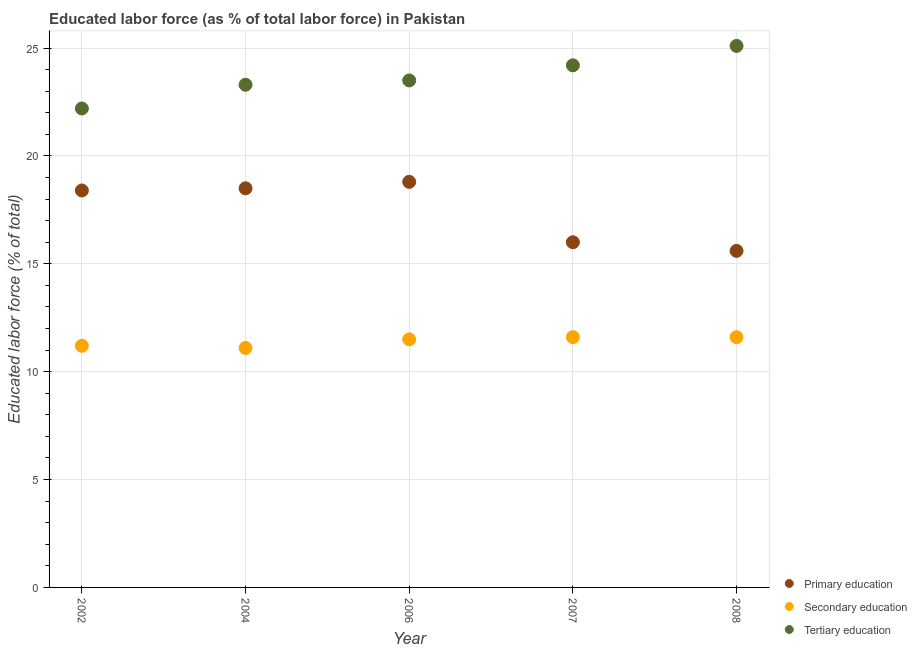How many different coloured dotlines are there?
Ensure brevity in your answer.  3. What is the percentage of labor force who received secondary education in 2002?
Make the answer very short. 11.2. Across all years, what is the maximum percentage of labor force who received secondary education?
Offer a very short reply. 11.6. Across all years, what is the minimum percentage of labor force who received tertiary education?
Your answer should be very brief. 22.2. In which year was the percentage of labor force who received tertiary education minimum?
Offer a terse response. 2002. What is the total percentage of labor force who received tertiary education in the graph?
Your response must be concise. 118.3. What is the difference between the percentage of labor force who received secondary education in 2006 and that in 2008?
Keep it short and to the point. -0.1. What is the difference between the percentage of labor force who received primary education in 2004 and the percentage of labor force who received tertiary education in 2008?
Your response must be concise. -6.6. What is the average percentage of labor force who received primary education per year?
Keep it short and to the point. 17.46. In the year 2004, what is the difference between the percentage of labor force who received primary education and percentage of labor force who received tertiary education?
Provide a short and direct response. -4.8. What is the ratio of the percentage of labor force who received primary education in 2002 to that in 2006?
Give a very brief answer. 0.98. What is the difference between the highest and the second highest percentage of labor force who received primary education?
Provide a succinct answer. 0.3. What is the difference between the highest and the lowest percentage of labor force who received primary education?
Provide a short and direct response. 3.2. Is it the case that in every year, the sum of the percentage of labor force who received primary education and percentage of labor force who received secondary education is greater than the percentage of labor force who received tertiary education?
Keep it short and to the point. Yes. Is the percentage of labor force who received primary education strictly greater than the percentage of labor force who received tertiary education over the years?
Make the answer very short. No. How many years are there in the graph?
Offer a very short reply. 5. What is the difference between two consecutive major ticks on the Y-axis?
Keep it short and to the point. 5. Are the values on the major ticks of Y-axis written in scientific E-notation?
Your response must be concise. No. Where does the legend appear in the graph?
Offer a very short reply. Bottom right. How many legend labels are there?
Provide a succinct answer. 3. What is the title of the graph?
Ensure brevity in your answer.  Educated labor force (as % of total labor force) in Pakistan. Does "Industrial Nitrous Oxide" appear as one of the legend labels in the graph?
Your answer should be compact. No. What is the label or title of the Y-axis?
Give a very brief answer. Educated labor force (% of total). What is the Educated labor force (% of total) of Primary education in 2002?
Keep it short and to the point. 18.4. What is the Educated labor force (% of total) of Secondary education in 2002?
Your response must be concise. 11.2. What is the Educated labor force (% of total) in Tertiary education in 2002?
Provide a succinct answer. 22.2. What is the Educated labor force (% of total) in Primary education in 2004?
Offer a very short reply. 18.5. What is the Educated labor force (% of total) in Secondary education in 2004?
Offer a terse response. 11.1. What is the Educated labor force (% of total) of Tertiary education in 2004?
Provide a succinct answer. 23.3. What is the Educated labor force (% of total) in Primary education in 2006?
Offer a very short reply. 18.8. What is the Educated labor force (% of total) in Tertiary education in 2006?
Your answer should be very brief. 23.5. What is the Educated labor force (% of total) in Primary education in 2007?
Your answer should be very brief. 16. What is the Educated labor force (% of total) of Secondary education in 2007?
Offer a terse response. 11.6. What is the Educated labor force (% of total) of Tertiary education in 2007?
Ensure brevity in your answer.  24.2. What is the Educated labor force (% of total) in Primary education in 2008?
Offer a terse response. 15.6. What is the Educated labor force (% of total) in Secondary education in 2008?
Keep it short and to the point. 11.6. What is the Educated labor force (% of total) in Tertiary education in 2008?
Your answer should be compact. 25.1. Across all years, what is the maximum Educated labor force (% of total) of Primary education?
Make the answer very short. 18.8. Across all years, what is the maximum Educated labor force (% of total) in Secondary education?
Keep it short and to the point. 11.6. Across all years, what is the maximum Educated labor force (% of total) of Tertiary education?
Offer a very short reply. 25.1. Across all years, what is the minimum Educated labor force (% of total) in Primary education?
Provide a short and direct response. 15.6. Across all years, what is the minimum Educated labor force (% of total) of Secondary education?
Offer a very short reply. 11.1. Across all years, what is the minimum Educated labor force (% of total) of Tertiary education?
Ensure brevity in your answer.  22.2. What is the total Educated labor force (% of total) in Primary education in the graph?
Keep it short and to the point. 87.3. What is the total Educated labor force (% of total) in Secondary education in the graph?
Offer a terse response. 57. What is the total Educated labor force (% of total) of Tertiary education in the graph?
Provide a succinct answer. 118.3. What is the difference between the Educated labor force (% of total) in Primary education in 2002 and that in 2004?
Your answer should be compact. -0.1. What is the difference between the Educated labor force (% of total) of Tertiary education in 2002 and that in 2004?
Offer a very short reply. -1.1. What is the difference between the Educated labor force (% of total) in Primary education in 2002 and that in 2006?
Your response must be concise. -0.4. What is the difference between the Educated labor force (% of total) in Primary education in 2002 and that in 2007?
Your answer should be very brief. 2.4. What is the difference between the Educated labor force (% of total) in Secondary education in 2002 and that in 2008?
Your answer should be very brief. -0.4. What is the difference between the Educated labor force (% of total) of Tertiary education in 2004 and that in 2007?
Provide a succinct answer. -0.9. What is the difference between the Educated labor force (% of total) in Primary education in 2004 and that in 2008?
Provide a short and direct response. 2.9. What is the difference between the Educated labor force (% of total) of Primary education in 2006 and that in 2007?
Provide a short and direct response. 2.8. What is the difference between the Educated labor force (% of total) in Primary education in 2006 and that in 2008?
Your answer should be compact. 3.2. What is the difference between the Educated labor force (% of total) of Secondary education in 2007 and that in 2008?
Make the answer very short. 0. What is the difference between the Educated labor force (% of total) in Primary education in 2002 and the Educated labor force (% of total) in Tertiary education in 2004?
Your answer should be very brief. -4.9. What is the difference between the Educated labor force (% of total) of Secondary education in 2002 and the Educated labor force (% of total) of Tertiary education in 2004?
Make the answer very short. -12.1. What is the difference between the Educated labor force (% of total) of Primary education in 2002 and the Educated labor force (% of total) of Secondary education in 2006?
Ensure brevity in your answer.  6.9. What is the difference between the Educated labor force (% of total) of Primary education in 2002 and the Educated labor force (% of total) of Secondary education in 2007?
Provide a short and direct response. 6.8. What is the difference between the Educated labor force (% of total) of Primary education in 2002 and the Educated labor force (% of total) of Tertiary education in 2007?
Offer a terse response. -5.8. What is the difference between the Educated labor force (% of total) in Primary education in 2002 and the Educated labor force (% of total) in Secondary education in 2008?
Provide a short and direct response. 6.8. What is the difference between the Educated labor force (% of total) in Primary education in 2002 and the Educated labor force (% of total) in Tertiary education in 2008?
Ensure brevity in your answer.  -6.7. What is the difference between the Educated labor force (% of total) of Primary education in 2004 and the Educated labor force (% of total) of Tertiary education in 2006?
Offer a terse response. -5. What is the difference between the Educated labor force (% of total) of Primary education in 2004 and the Educated labor force (% of total) of Secondary education in 2007?
Your answer should be compact. 6.9. What is the difference between the Educated labor force (% of total) of Primary education in 2004 and the Educated labor force (% of total) of Tertiary education in 2007?
Your response must be concise. -5.7. What is the difference between the Educated labor force (% of total) of Primary education in 2004 and the Educated labor force (% of total) of Secondary education in 2008?
Offer a terse response. 6.9. What is the difference between the Educated labor force (% of total) of Primary education in 2004 and the Educated labor force (% of total) of Tertiary education in 2008?
Provide a succinct answer. -6.6. What is the difference between the Educated labor force (% of total) in Primary education in 2006 and the Educated labor force (% of total) in Secondary education in 2007?
Your answer should be very brief. 7.2. What is the difference between the Educated labor force (% of total) in Primary education in 2006 and the Educated labor force (% of total) in Tertiary education in 2008?
Keep it short and to the point. -6.3. What is the difference between the Educated labor force (% of total) in Secondary education in 2006 and the Educated labor force (% of total) in Tertiary education in 2008?
Give a very brief answer. -13.6. What is the difference between the Educated labor force (% of total) of Primary education in 2007 and the Educated labor force (% of total) of Secondary education in 2008?
Offer a terse response. 4.4. What is the average Educated labor force (% of total) in Primary education per year?
Offer a terse response. 17.46. What is the average Educated labor force (% of total) of Tertiary education per year?
Give a very brief answer. 23.66. In the year 2002, what is the difference between the Educated labor force (% of total) in Primary education and Educated labor force (% of total) in Tertiary education?
Your answer should be very brief. -3.8. In the year 2002, what is the difference between the Educated labor force (% of total) of Secondary education and Educated labor force (% of total) of Tertiary education?
Ensure brevity in your answer.  -11. In the year 2006, what is the difference between the Educated labor force (% of total) of Primary education and Educated labor force (% of total) of Secondary education?
Give a very brief answer. 7.3. In the year 2007, what is the difference between the Educated labor force (% of total) of Secondary education and Educated labor force (% of total) of Tertiary education?
Provide a succinct answer. -12.6. In the year 2008, what is the difference between the Educated labor force (% of total) of Primary education and Educated labor force (% of total) of Secondary education?
Your answer should be compact. 4. In the year 2008, what is the difference between the Educated labor force (% of total) of Primary education and Educated labor force (% of total) of Tertiary education?
Ensure brevity in your answer.  -9.5. What is the ratio of the Educated labor force (% of total) in Tertiary education in 2002 to that in 2004?
Keep it short and to the point. 0.95. What is the ratio of the Educated labor force (% of total) in Primary education in 2002 to that in 2006?
Provide a succinct answer. 0.98. What is the ratio of the Educated labor force (% of total) of Secondary education in 2002 to that in 2006?
Ensure brevity in your answer.  0.97. What is the ratio of the Educated labor force (% of total) of Tertiary education in 2002 to that in 2006?
Make the answer very short. 0.94. What is the ratio of the Educated labor force (% of total) of Primary education in 2002 to that in 2007?
Keep it short and to the point. 1.15. What is the ratio of the Educated labor force (% of total) of Secondary education in 2002 to that in 2007?
Provide a short and direct response. 0.97. What is the ratio of the Educated labor force (% of total) of Tertiary education in 2002 to that in 2007?
Your answer should be very brief. 0.92. What is the ratio of the Educated labor force (% of total) of Primary education in 2002 to that in 2008?
Ensure brevity in your answer.  1.18. What is the ratio of the Educated labor force (% of total) of Secondary education in 2002 to that in 2008?
Offer a very short reply. 0.97. What is the ratio of the Educated labor force (% of total) of Tertiary education in 2002 to that in 2008?
Ensure brevity in your answer.  0.88. What is the ratio of the Educated labor force (% of total) of Secondary education in 2004 to that in 2006?
Keep it short and to the point. 0.97. What is the ratio of the Educated labor force (% of total) of Tertiary education in 2004 to that in 2006?
Provide a short and direct response. 0.99. What is the ratio of the Educated labor force (% of total) of Primary education in 2004 to that in 2007?
Make the answer very short. 1.16. What is the ratio of the Educated labor force (% of total) in Secondary education in 2004 to that in 2007?
Make the answer very short. 0.96. What is the ratio of the Educated labor force (% of total) in Tertiary education in 2004 to that in 2007?
Keep it short and to the point. 0.96. What is the ratio of the Educated labor force (% of total) of Primary education in 2004 to that in 2008?
Provide a short and direct response. 1.19. What is the ratio of the Educated labor force (% of total) of Secondary education in 2004 to that in 2008?
Ensure brevity in your answer.  0.96. What is the ratio of the Educated labor force (% of total) of Tertiary education in 2004 to that in 2008?
Offer a very short reply. 0.93. What is the ratio of the Educated labor force (% of total) in Primary education in 2006 to that in 2007?
Ensure brevity in your answer.  1.18. What is the ratio of the Educated labor force (% of total) of Tertiary education in 2006 to that in 2007?
Offer a very short reply. 0.97. What is the ratio of the Educated labor force (% of total) of Primary education in 2006 to that in 2008?
Ensure brevity in your answer.  1.21. What is the ratio of the Educated labor force (% of total) in Tertiary education in 2006 to that in 2008?
Ensure brevity in your answer.  0.94. What is the ratio of the Educated labor force (% of total) of Primary education in 2007 to that in 2008?
Offer a terse response. 1.03. What is the ratio of the Educated labor force (% of total) of Secondary education in 2007 to that in 2008?
Give a very brief answer. 1. What is the ratio of the Educated labor force (% of total) of Tertiary education in 2007 to that in 2008?
Keep it short and to the point. 0.96. What is the difference between the highest and the second highest Educated labor force (% of total) of Secondary education?
Give a very brief answer. 0. What is the difference between the highest and the second highest Educated labor force (% of total) of Tertiary education?
Give a very brief answer. 0.9. What is the difference between the highest and the lowest Educated labor force (% of total) of Primary education?
Make the answer very short. 3.2. 